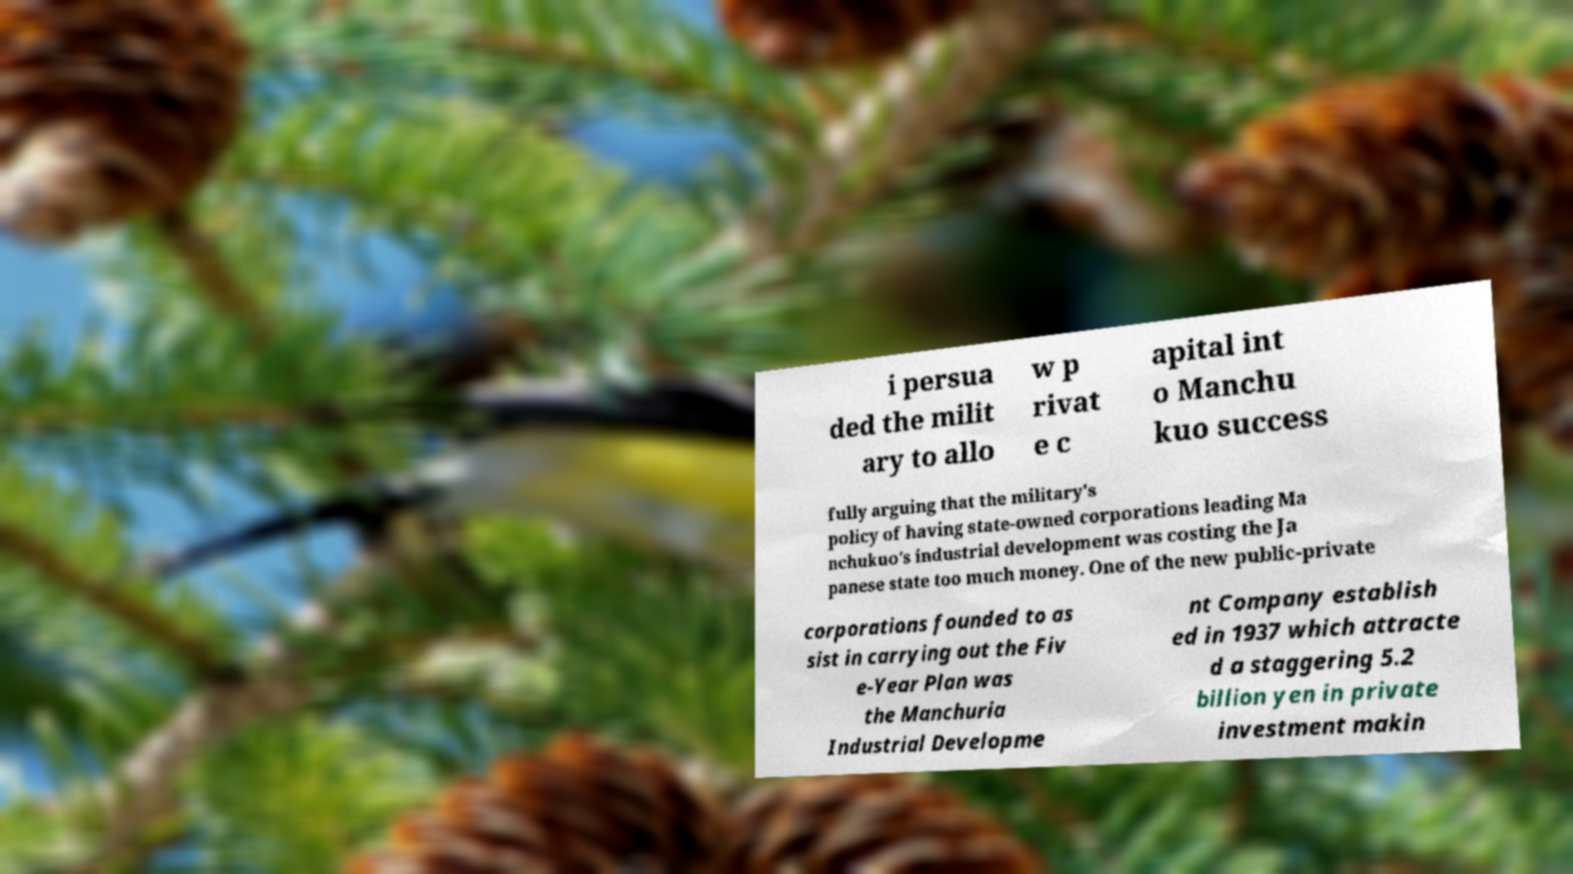Could you assist in decoding the text presented in this image and type it out clearly? i persua ded the milit ary to allo w p rivat e c apital int o Manchu kuo success fully arguing that the military's policy of having state-owned corporations leading Ma nchukuo's industrial development was costing the Ja panese state too much money. One of the new public-private corporations founded to as sist in carrying out the Fiv e-Year Plan was the Manchuria Industrial Developme nt Company establish ed in 1937 which attracte d a staggering 5.2 billion yen in private investment makin 